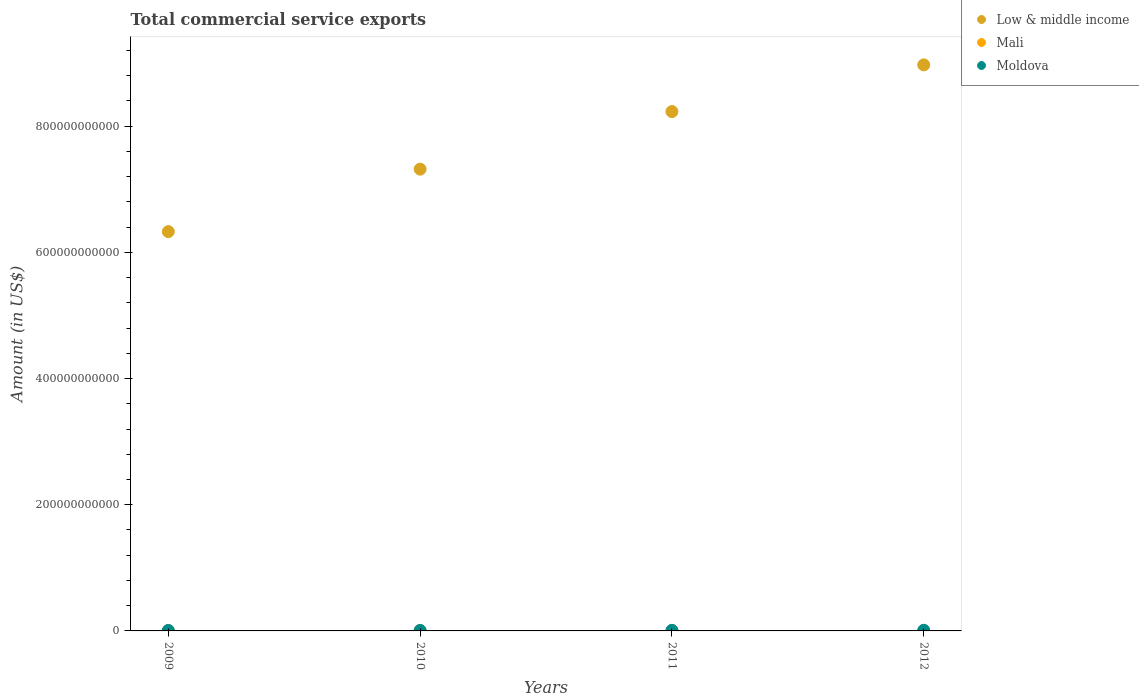What is the total commercial service exports in Mali in 2011?
Ensure brevity in your answer.  3.79e+08. Across all years, what is the maximum total commercial service exports in Low & middle income?
Offer a terse response. 8.97e+11. Across all years, what is the minimum total commercial service exports in Low & middle income?
Keep it short and to the point. 6.33e+11. In which year was the total commercial service exports in Mali maximum?
Provide a succinct answer. 2011. In which year was the total commercial service exports in Moldova minimum?
Your answer should be very brief. 2010. What is the total total commercial service exports in Moldova in the graph?
Give a very brief answer. 3.42e+09. What is the difference between the total commercial service exports in Low & middle income in 2010 and that in 2011?
Provide a succinct answer. -9.13e+1. What is the difference between the total commercial service exports in Low & middle income in 2009 and the total commercial service exports in Mali in 2012?
Ensure brevity in your answer.  6.33e+11. What is the average total commercial service exports in Mali per year?
Your response must be concise. 3.46e+08. In the year 2011, what is the difference between the total commercial service exports in Mali and total commercial service exports in Low & middle income?
Offer a very short reply. -8.23e+11. What is the ratio of the total commercial service exports in Mali in 2009 to that in 2011?
Your response must be concise. 0.89. What is the difference between the highest and the second highest total commercial service exports in Mali?
Give a very brief answer. 2.30e+07. What is the difference between the highest and the lowest total commercial service exports in Mali?
Ensure brevity in your answer.  6.72e+07. Is the sum of the total commercial service exports in Mali in 2011 and 2012 greater than the maximum total commercial service exports in Low & middle income across all years?
Give a very brief answer. No. How many dotlines are there?
Make the answer very short. 3. What is the difference between two consecutive major ticks on the Y-axis?
Your response must be concise. 2.00e+11. Does the graph contain grids?
Offer a very short reply. No. Where does the legend appear in the graph?
Your answer should be compact. Top right. How are the legend labels stacked?
Offer a very short reply. Vertical. What is the title of the graph?
Keep it short and to the point. Total commercial service exports. Does "Namibia" appear as one of the legend labels in the graph?
Provide a short and direct response. No. What is the label or title of the X-axis?
Give a very brief answer. Years. What is the Amount (in US$) in Low & middle income in 2009?
Provide a succinct answer. 6.33e+11. What is the Amount (in US$) of Mali in 2009?
Keep it short and to the point. 3.36e+08. What is the Amount (in US$) of Moldova in 2009?
Offer a terse response. 7.64e+08. What is the Amount (in US$) in Low & middle income in 2010?
Offer a terse response. 7.32e+11. What is the Amount (in US$) in Mali in 2010?
Your answer should be very brief. 3.56e+08. What is the Amount (in US$) of Moldova in 2010?
Keep it short and to the point. 7.45e+08. What is the Amount (in US$) in Low & middle income in 2011?
Your answer should be compact. 8.23e+11. What is the Amount (in US$) in Mali in 2011?
Make the answer very short. 3.79e+08. What is the Amount (in US$) in Moldova in 2011?
Make the answer very short. 9.18e+08. What is the Amount (in US$) of Low & middle income in 2012?
Your answer should be compact. 8.97e+11. What is the Amount (in US$) of Mali in 2012?
Provide a short and direct response. 3.12e+08. What is the Amount (in US$) of Moldova in 2012?
Your answer should be compact. 9.95e+08. Across all years, what is the maximum Amount (in US$) in Low & middle income?
Make the answer very short. 8.97e+11. Across all years, what is the maximum Amount (in US$) of Mali?
Offer a terse response. 3.79e+08. Across all years, what is the maximum Amount (in US$) in Moldova?
Your answer should be very brief. 9.95e+08. Across all years, what is the minimum Amount (in US$) of Low & middle income?
Ensure brevity in your answer.  6.33e+11. Across all years, what is the minimum Amount (in US$) of Mali?
Offer a terse response. 3.12e+08. Across all years, what is the minimum Amount (in US$) in Moldova?
Your answer should be compact. 7.45e+08. What is the total Amount (in US$) of Low & middle income in the graph?
Your response must be concise. 3.09e+12. What is the total Amount (in US$) in Mali in the graph?
Your response must be concise. 1.38e+09. What is the total Amount (in US$) in Moldova in the graph?
Your answer should be compact. 3.42e+09. What is the difference between the Amount (in US$) in Low & middle income in 2009 and that in 2010?
Keep it short and to the point. -9.90e+1. What is the difference between the Amount (in US$) in Mali in 2009 and that in 2010?
Your answer should be very brief. -1.92e+07. What is the difference between the Amount (in US$) of Moldova in 2009 and that in 2010?
Your response must be concise. 1.86e+07. What is the difference between the Amount (in US$) in Low & middle income in 2009 and that in 2011?
Your answer should be very brief. -1.90e+11. What is the difference between the Amount (in US$) of Mali in 2009 and that in 2011?
Offer a very short reply. -4.23e+07. What is the difference between the Amount (in US$) in Moldova in 2009 and that in 2011?
Provide a succinct answer. -1.54e+08. What is the difference between the Amount (in US$) in Low & middle income in 2009 and that in 2012?
Make the answer very short. -2.64e+11. What is the difference between the Amount (in US$) in Mali in 2009 and that in 2012?
Make the answer very short. 2.49e+07. What is the difference between the Amount (in US$) in Moldova in 2009 and that in 2012?
Your response must be concise. -2.31e+08. What is the difference between the Amount (in US$) of Low & middle income in 2010 and that in 2011?
Your response must be concise. -9.13e+1. What is the difference between the Amount (in US$) of Mali in 2010 and that in 2011?
Keep it short and to the point. -2.30e+07. What is the difference between the Amount (in US$) in Moldova in 2010 and that in 2011?
Provide a short and direct response. -1.73e+08. What is the difference between the Amount (in US$) in Low & middle income in 2010 and that in 2012?
Your answer should be very brief. -1.65e+11. What is the difference between the Amount (in US$) of Mali in 2010 and that in 2012?
Offer a terse response. 4.41e+07. What is the difference between the Amount (in US$) of Moldova in 2010 and that in 2012?
Ensure brevity in your answer.  -2.50e+08. What is the difference between the Amount (in US$) in Low & middle income in 2011 and that in 2012?
Your answer should be compact. -7.40e+1. What is the difference between the Amount (in US$) in Mali in 2011 and that in 2012?
Ensure brevity in your answer.  6.72e+07. What is the difference between the Amount (in US$) in Moldova in 2011 and that in 2012?
Ensure brevity in your answer.  -7.69e+07. What is the difference between the Amount (in US$) in Low & middle income in 2009 and the Amount (in US$) in Mali in 2010?
Give a very brief answer. 6.33e+11. What is the difference between the Amount (in US$) of Low & middle income in 2009 and the Amount (in US$) of Moldova in 2010?
Your response must be concise. 6.32e+11. What is the difference between the Amount (in US$) in Mali in 2009 and the Amount (in US$) in Moldova in 2010?
Provide a succinct answer. -4.09e+08. What is the difference between the Amount (in US$) of Low & middle income in 2009 and the Amount (in US$) of Mali in 2011?
Ensure brevity in your answer.  6.33e+11. What is the difference between the Amount (in US$) of Low & middle income in 2009 and the Amount (in US$) of Moldova in 2011?
Offer a very short reply. 6.32e+11. What is the difference between the Amount (in US$) of Mali in 2009 and the Amount (in US$) of Moldova in 2011?
Provide a succinct answer. -5.82e+08. What is the difference between the Amount (in US$) in Low & middle income in 2009 and the Amount (in US$) in Mali in 2012?
Offer a terse response. 6.33e+11. What is the difference between the Amount (in US$) of Low & middle income in 2009 and the Amount (in US$) of Moldova in 2012?
Your answer should be very brief. 6.32e+11. What is the difference between the Amount (in US$) of Mali in 2009 and the Amount (in US$) of Moldova in 2012?
Make the answer very short. -6.59e+08. What is the difference between the Amount (in US$) of Low & middle income in 2010 and the Amount (in US$) of Mali in 2011?
Your response must be concise. 7.32e+11. What is the difference between the Amount (in US$) in Low & middle income in 2010 and the Amount (in US$) in Moldova in 2011?
Provide a succinct answer. 7.31e+11. What is the difference between the Amount (in US$) in Mali in 2010 and the Amount (in US$) in Moldova in 2011?
Your answer should be compact. -5.62e+08. What is the difference between the Amount (in US$) of Low & middle income in 2010 and the Amount (in US$) of Mali in 2012?
Your answer should be very brief. 7.32e+11. What is the difference between the Amount (in US$) in Low & middle income in 2010 and the Amount (in US$) in Moldova in 2012?
Make the answer very short. 7.31e+11. What is the difference between the Amount (in US$) in Mali in 2010 and the Amount (in US$) in Moldova in 2012?
Provide a succinct answer. -6.39e+08. What is the difference between the Amount (in US$) in Low & middle income in 2011 and the Amount (in US$) in Mali in 2012?
Offer a terse response. 8.23e+11. What is the difference between the Amount (in US$) of Low & middle income in 2011 and the Amount (in US$) of Moldova in 2012?
Provide a short and direct response. 8.22e+11. What is the difference between the Amount (in US$) of Mali in 2011 and the Amount (in US$) of Moldova in 2012?
Offer a terse response. -6.16e+08. What is the average Amount (in US$) of Low & middle income per year?
Your answer should be compact. 7.71e+11. What is the average Amount (in US$) of Mali per year?
Offer a terse response. 3.46e+08. What is the average Amount (in US$) of Moldova per year?
Make the answer very short. 8.56e+08. In the year 2009, what is the difference between the Amount (in US$) in Low & middle income and Amount (in US$) in Mali?
Give a very brief answer. 6.33e+11. In the year 2009, what is the difference between the Amount (in US$) in Low & middle income and Amount (in US$) in Moldova?
Provide a succinct answer. 6.32e+11. In the year 2009, what is the difference between the Amount (in US$) of Mali and Amount (in US$) of Moldova?
Ensure brevity in your answer.  -4.28e+08. In the year 2010, what is the difference between the Amount (in US$) in Low & middle income and Amount (in US$) in Mali?
Provide a short and direct response. 7.32e+11. In the year 2010, what is the difference between the Amount (in US$) in Low & middle income and Amount (in US$) in Moldova?
Keep it short and to the point. 7.31e+11. In the year 2010, what is the difference between the Amount (in US$) in Mali and Amount (in US$) in Moldova?
Offer a very short reply. -3.90e+08. In the year 2011, what is the difference between the Amount (in US$) of Low & middle income and Amount (in US$) of Mali?
Provide a succinct answer. 8.23e+11. In the year 2011, what is the difference between the Amount (in US$) of Low & middle income and Amount (in US$) of Moldova?
Your response must be concise. 8.22e+11. In the year 2011, what is the difference between the Amount (in US$) in Mali and Amount (in US$) in Moldova?
Give a very brief answer. -5.39e+08. In the year 2012, what is the difference between the Amount (in US$) of Low & middle income and Amount (in US$) of Mali?
Your answer should be compact. 8.97e+11. In the year 2012, what is the difference between the Amount (in US$) of Low & middle income and Amount (in US$) of Moldova?
Make the answer very short. 8.96e+11. In the year 2012, what is the difference between the Amount (in US$) of Mali and Amount (in US$) of Moldova?
Your response must be concise. -6.83e+08. What is the ratio of the Amount (in US$) of Low & middle income in 2009 to that in 2010?
Provide a short and direct response. 0.86. What is the ratio of the Amount (in US$) in Mali in 2009 to that in 2010?
Make the answer very short. 0.95. What is the ratio of the Amount (in US$) in Low & middle income in 2009 to that in 2011?
Offer a terse response. 0.77. What is the ratio of the Amount (in US$) of Mali in 2009 to that in 2011?
Make the answer very short. 0.89. What is the ratio of the Amount (in US$) of Moldova in 2009 to that in 2011?
Make the answer very short. 0.83. What is the ratio of the Amount (in US$) of Low & middle income in 2009 to that in 2012?
Your response must be concise. 0.71. What is the ratio of the Amount (in US$) in Mali in 2009 to that in 2012?
Make the answer very short. 1.08. What is the ratio of the Amount (in US$) of Moldova in 2009 to that in 2012?
Keep it short and to the point. 0.77. What is the ratio of the Amount (in US$) of Low & middle income in 2010 to that in 2011?
Offer a very short reply. 0.89. What is the ratio of the Amount (in US$) in Mali in 2010 to that in 2011?
Provide a succinct answer. 0.94. What is the ratio of the Amount (in US$) of Moldova in 2010 to that in 2011?
Make the answer very short. 0.81. What is the ratio of the Amount (in US$) in Low & middle income in 2010 to that in 2012?
Give a very brief answer. 0.82. What is the ratio of the Amount (in US$) in Mali in 2010 to that in 2012?
Offer a terse response. 1.14. What is the ratio of the Amount (in US$) in Moldova in 2010 to that in 2012?
Give a very brief answer. 0.75. What is the ratio of the Amount (in US$) in Low & middle income in 2011 to that in 2012?
Offer a terse response. 0.92. What is the ratio of the Amount (in US$) in Mali in 2011 to that in 2012?
Your response must be concise. 1.22. What is the ratio of the Amount (in US$) in Moldova in 2011 to that in 2012?
Provide a short and direct response. 0.92. What is the difference between the highest and the second highest Amount (in US$) of Low & middle income?
Ensure brevity in your answer.  7.40e+1. What is the difference between the highest and the second highest Amount (in US$) in Mali?
Offer a very short reply. 2.30e+07. What is the difference between the highest and the second highest Amount (in US$) of Moldova?
Offer a very short reply. 7.69e+07. What is the difference between the highest and the lowest Amount (in US$) in Low & middle income?
Your answer should be very brief. 2.64e+11. What is the difference between the highest and the lowest Amount (in US$) of Mali?
Ensure brevity in your answer.  6.72e+07. What is the difference between the highest and the lowest Amount (in US$) in Moldova?
Your answer should be very brief. 2.50e+08. 